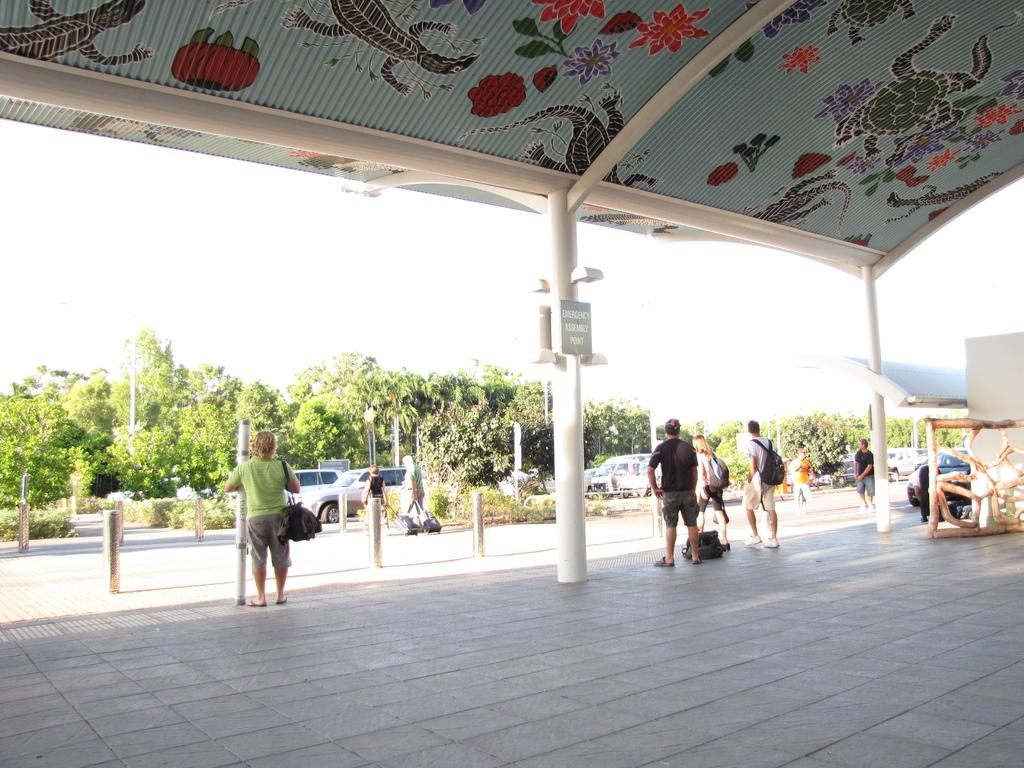What are the persons in the image doing? The persons in the image are walking. On what surface are the persons walking? The persons are walking on a floor. What can be seen in the background of the image? There are vehicles moving and trees visible in the background of the image. What is the condition of the sky in the background of the image? The sky is clear in the background of the image. What type of brick is used to build the dinner table in the image? There is no dinner table present in the image, and therefore no brick can be associated with it. What type of lock is visible on the vehicle in the image? There is no vehicle with a lock visible in the image. 